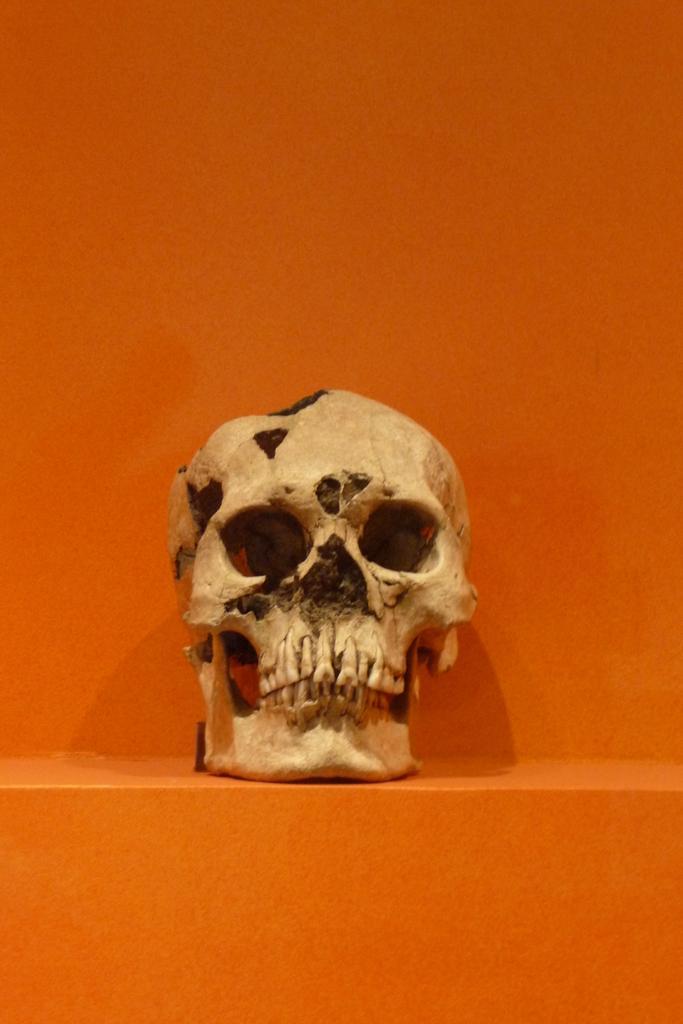How would you summarize this image in a sentence or two? In this image, we can see a skull on the orange surface. Background we can see orange color wall. 